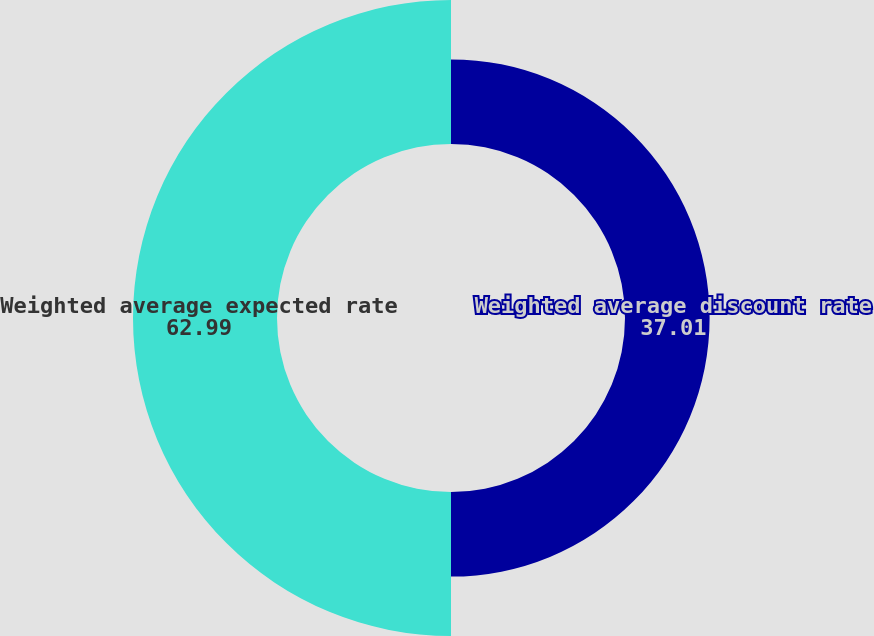<chart> <loc_0><loc_0><loc_500><loc_500><pie_chart><fcel>Weighted average discount rate<fcel>Weighted average expected rate<nl><fcel>37.01%<fcel>62.99%<nl></chart> 